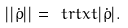Convert formula to latex. <formula><loc_0><loc_0><loc_500><loc_500>| | \dot { \rho } | | = \ t r t x t { | \dot { \rho } | } .</formula> 